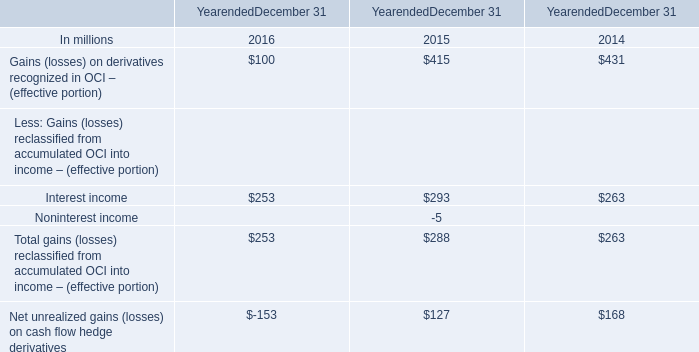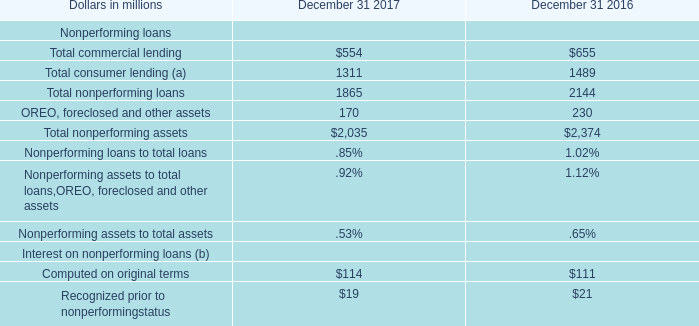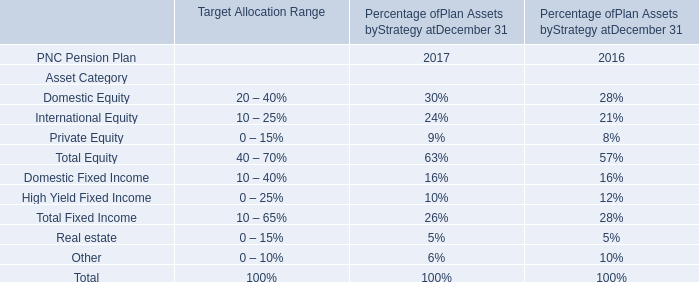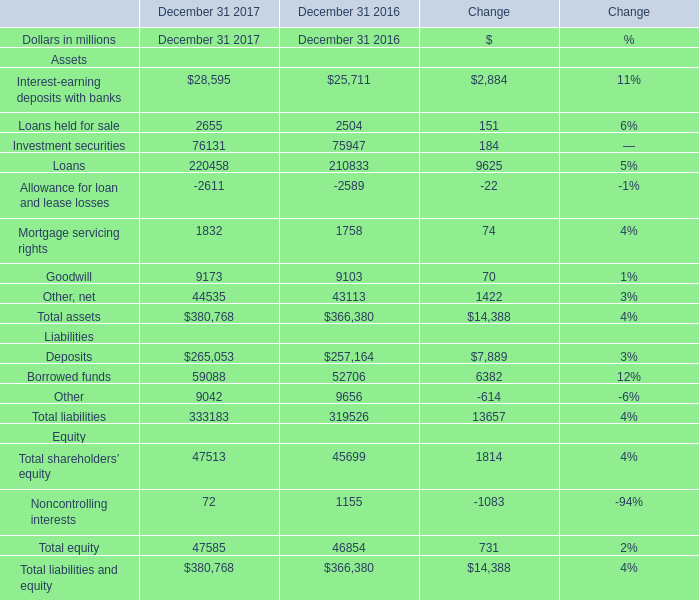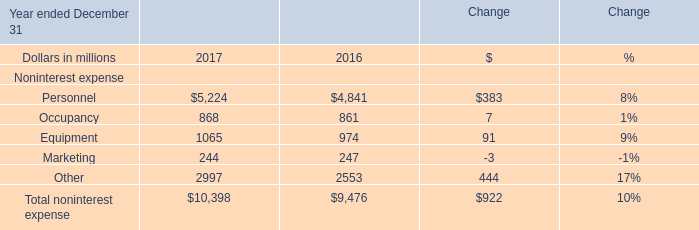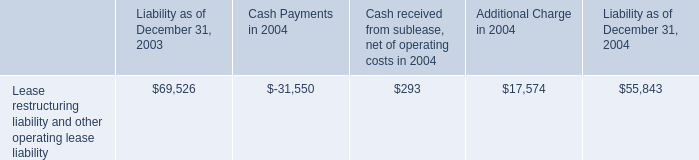what is the percent of the in the non operating income associated with interest income in 2005 
Computations: (1.7 / 10.3)
Answer: 0.16505. 